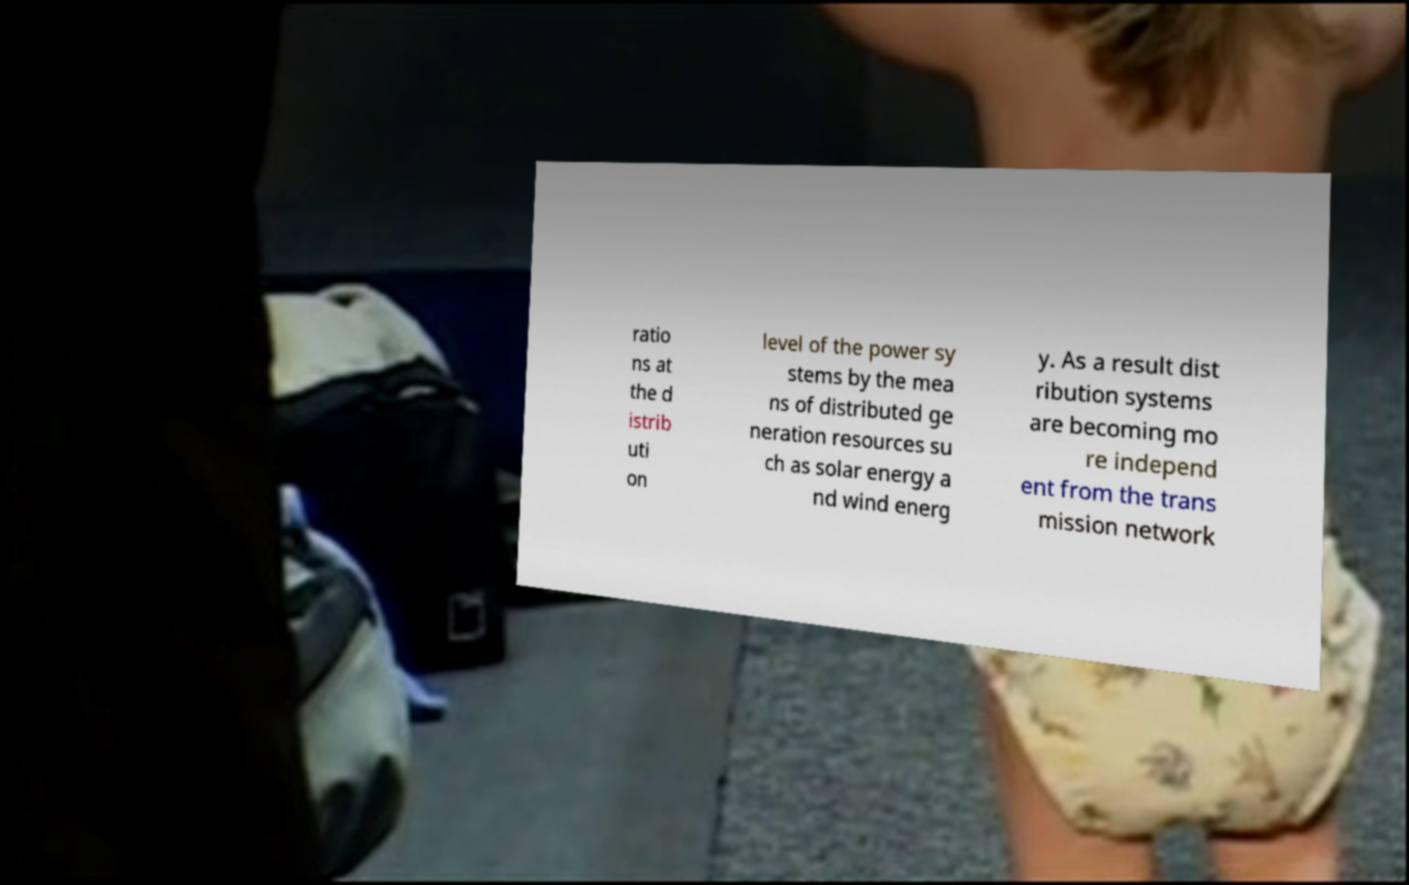Can you read and provide the text displayed in the image?This photo seems to have some interesting text. Can you extract and type it out for me? ratio ns at the d istrib uti on level of the power sy stems by the mea ns of distributed ge neration resources su ch as solar energy a nd wind energ y. As a result dist ribution systems are becoming mo re independ ent from the trans mission network 